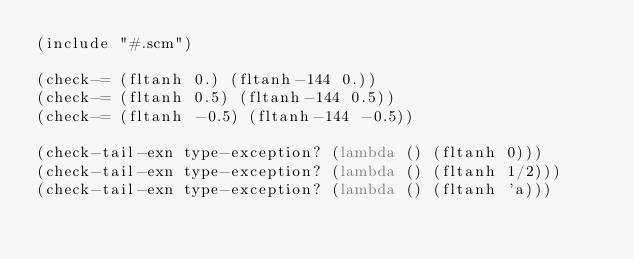<code> <loc_0><loc_0><loc_500><loc_500><_Scheme_>(include "#.scm")

(check-= (fltanh 0.) (fltanh-144 0.))
(check-= (fltanh 0.5) (fltanh-144 0.5))
(check-= (fltanh -0.5) (fltanh-144 -0.5))

(check-tail-exn type-exception? (lambda () (fltanh 0)))
(check-tail-exn type-exception? (lambda () (fltanh 1/2)))
(check-tail-exn type-exception? (lambda () (fltanh 'a)))
</code> 